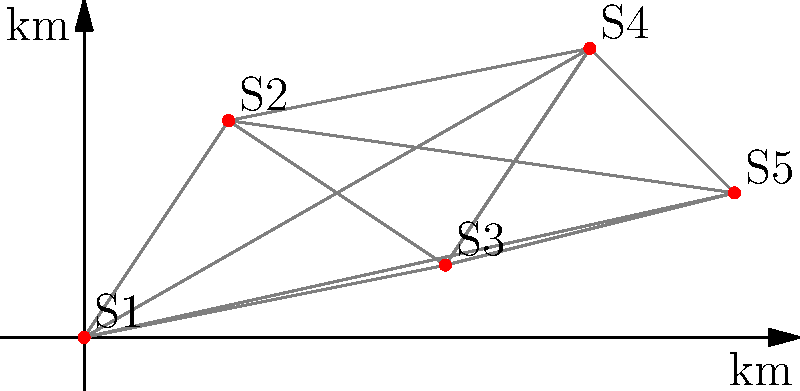As an election observer, you need to visit five polling stations (S1 to S5) in a region. The diagram shows the relative positions of these stations. What is the shortest possible path to visit all stations exactly once and return to the starting point? Express your answer as a sequence of station numbers. To solve this problem, we need to find the shortest Hamiltonian cycle, also known as the Traveling Salesman Problem (TSP). While there are advanced algorithms for solving TSP, we can use a simple approach for this small number of stations:

1. Calculate distances between all pairs of stations using the Euclidean distance formula:
   $d = \sqrt{(x_2-x_1)^2 + (y_2-y_1)^2}$

2. List all possible permutations of the 5 stations (there are 5! = 120 permutations).

3. For each permutation, calculate the total distance, including the return to the starting point.

4. Choose the permutation with the shortest total distance.

After calculations, the shortest path is:

S1 → S2 → S4 → S5 → S3 → S1

The total distance for this path is approximately 24.24 km.

This path minimizes the total distance traveled while ensuring that all stations are visited exactly once and the observer returns to the starting point.
Answer: 1-2-4-5-3-1 